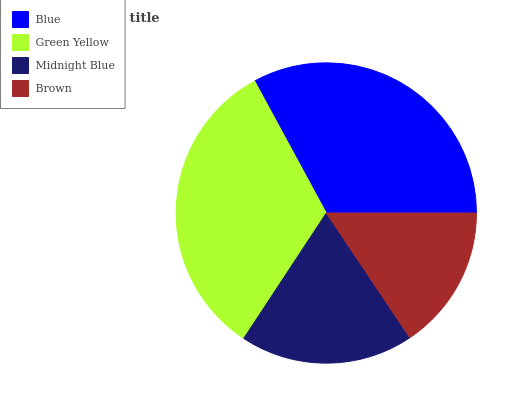Is Brown the minimum?
Answer yes or no. Yes. Is Blue the maximum?
Answer yes or no. Yes. Is Green Yellow the minimum?
Answer yes or no. No. Is Green Yellow the maximum?
Answer yes or no. No. Is Blue greater than Green Yellow?
Answer yes or no. Yes. Is Green Yellow less than Blue?
Answer yes or no. Yes. Is Green Yellow greater than Blue?
Answer yes or no. No. Is Blue less than Green Yellow?
Answer yes or no. No. Is Green Yellow the high median?
Answer yes or no. Yes. Is Midnight Blue the low median?
Answer yes or no. Yes. Is Midnight Blue the high median?
Answer yes or no. No. Is Brown the low median?
Answer yes or no. No. 